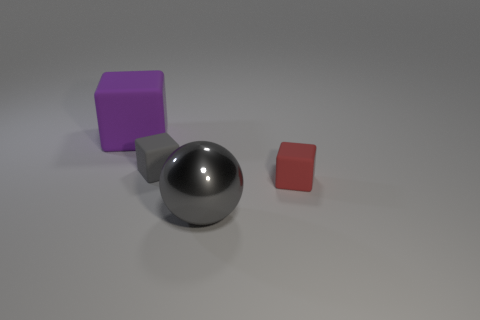How many things are left of the tiny red object and to the right of the gray matte object?
Give a very brief answer. 1. Is the size of the gray ball the same as the gray object that is behind the tiny red rubber thing?
Your response must be concise. No. Are there any tiny matte blocks to the right of the tiny cube behind the small thing that is in front of the small gray matte thing?
Provide a short and direct response. Yes. There is a object that is to the right of the large thing on the right side of the big purple object; what is its material?
Provide a short and direct response. Rubber. There is a cube that is both on the left side of the large sphere and right of the big purple matte thing; what is its material?
Your answer should be very brief. Rubber. Are there any big purple matte things that have the same shape as the big metal thing?
Keep it short and to the point. No. Are there any small things behind the large thing in front of the big matte thing?
Offer a very short reply. Yes. What number of small purple cylinders have the same material as the purple thing?
Your answer should be compact. 0. Are any small blue spheres visible?
Give a very brief answer. No. How many cubes are the same color as the big metallic ball?
Give a very brief answer. 1. 